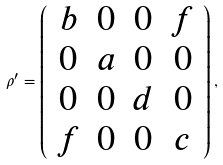Convert formula to latex. <formula><loc_0><loc_0><loc_500><loc_500>\rho ^ { \prime } = \left ( \begin{array} { c c c c } b & 0 & 0 & f \\ 0 & a & 0 & 0 \\ 0 & 0 & d & 0 \\ f & 0 & 0 & c \\ \end{array} \right ) ,</formula> 